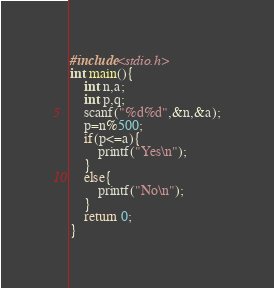Convert code to text. <code><loc_0><loc_0><loc_500><loc_500><_C_>#include<stdio.h>
int main(){
	int n,a;
	int p,q;
	scanf("%d%d",&n,&a);
	p=n%500;
	if(p<=a){
		printf("Yes\n");
	}
	else{
		printf("No\n");
	}
	return 0;
}</code> 